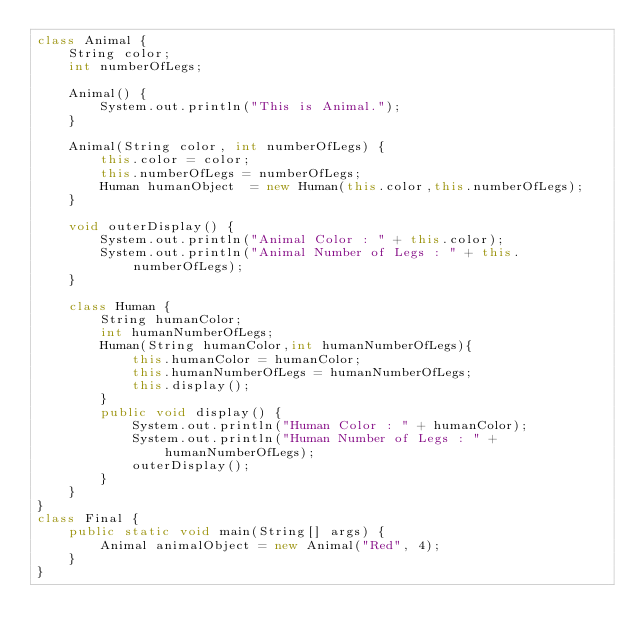Convert code to text. <code><loc_0><loc_0><loc_500><loc_500><_Java_>class Animal {
    String color;
    int numberOfLegs;

    Animal() {
        System.out.println("This is Animal.");
    }

    Animal(String color, int numberOfLegs) {
        this.color = color;
        this.numberOfLegs = numberOfLegs;
        Human humanObject  = new Human(this.color,this.numberOfLegs);
    }

    void outerDisplay() {
        System.out.println("Animal Color : " + this.color);
        System.out.println("Animal Number of Legs : " + this.numberOfLegs);
    }

    class Human {
        String humanColor;
        int humanNumberOfLegs;
        Human(String humanColor,int humanNumberOfLegs){
            this.humanColor = humanColor;
            this.humanNumberOfLegs = humanNumberOfLegs;
            this.display();
        }
        public void display() {
            System.out.println("Human Color : " + humanColor);
            System.out.println("Human Number of Legs : " + humanNumberOfLegs);
            outerDisplay();
        }
    }
}
class Final {
    public static void main(String[] args) {
        Animal animalObject = new Animal("Red", 4);
    }
}</code> 